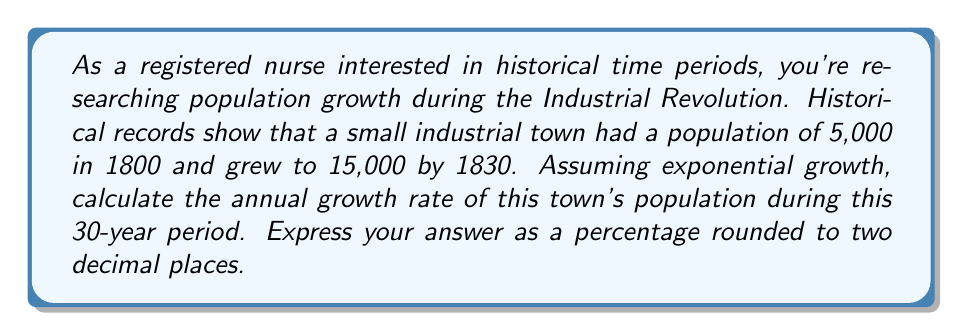Can you solve this math problem? To solve this problem, we'll use the exponential growth formula:

$$A = P(1 + r)^t$$

Where:
$A$ = Final amount (population)
$P$ = Initial amount (population)
$r$ = Annual growth rate (in decimal form)
$t$ = Time period (in years)

Given:
$P = 5,000$ (population in 1800)
$A = 15,000$ (population in 1830)
$t = 30$ years

Let's plug these values into the formula:

$$15,000 = 5,000(1 + r)^{30}$$

Now, let's solve for $r$:

1) Divide both sides by 5,000:
   $$3 = (1 + r)^{30}$$

2) Take the 30th root of both sides:
   $$\sqrt[30]{3} = 1 + r$$

3) Subtract 1 from both sides:
   $$\sqrt[30]{3} - 1 = r$$

4) Calculate the value:
   $$r \approx 0.03712$$

5) Convert to a percentage:
   $$r \approx 3.712\%$$

Rounding to two decimal places: 3.71%
Answer: The annual population growth rate of the industrial town between 1800 and 1830 was approximately 3.71%. 